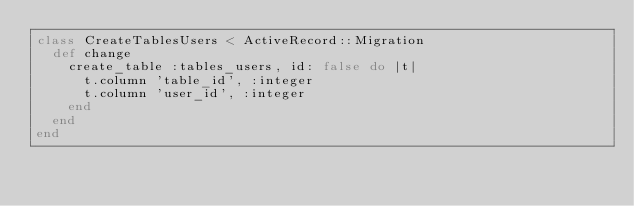<code> <loc_0><loc_0><loc_500><loc_500><_Ruby_>class CreateTablesUsers < ActiveRecord::Migration
  def change
    create_table :tables_users, id: false do |t|
      t.column 'table_id', :integer
      t.column 'user_id', :integer
    end
  end
end
</code> 